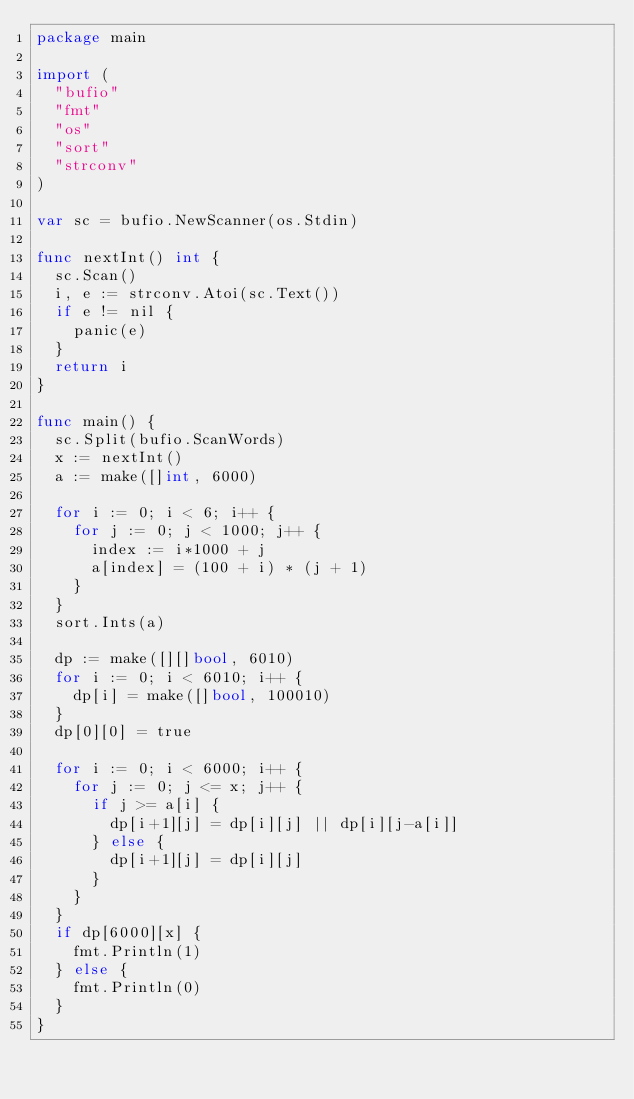Convert code to text. <code><loc_0><loc_0><loc_500><loc_500><_Go_>package main

import (
	"bufio"
	"fmt"
	"os"
	"sort"
	"strconv"
)

var sc = bufio.NewScanner(os.Stdin)

func nextInt() int {
	sc.Scan()
	i, e := strconv.Atoi(sc.Text())
	if e != nil {
		panic(e)
	}
	return i
}

func main() {
	sc.Split(bufio.ScanWords)
	x := nextInt()
	a := make([]int, 6000)

	for i := 0; i < 6; i++ {
		for j := 0; j < 1000; j++ {
			index := i*1000 + j
			a[index] = (100 + i) * (j + 1)
		}
	}
	sort.Ints(a)

	dp := make([][]bool, 6010)
	for i := 0; i < 6010; i++ {
		dp[i] = make([]bool, 100010)
	}
	dp[0][0] = true

	for i := 0; i < 6000; i++ {
		for j := 0; j <= x; j++ {
			if j >= a[i] {
				dp[i+1][j] = dp[i][j] || dp[i][j-a[i]]
			} else {
				dp[i+1][j] = dp[i][j]
			}
		}
	}
	if dp[6000][x] {
		fmt.Println(1)
	} else {
		fmt.Println(0)
	}
}
</code> 